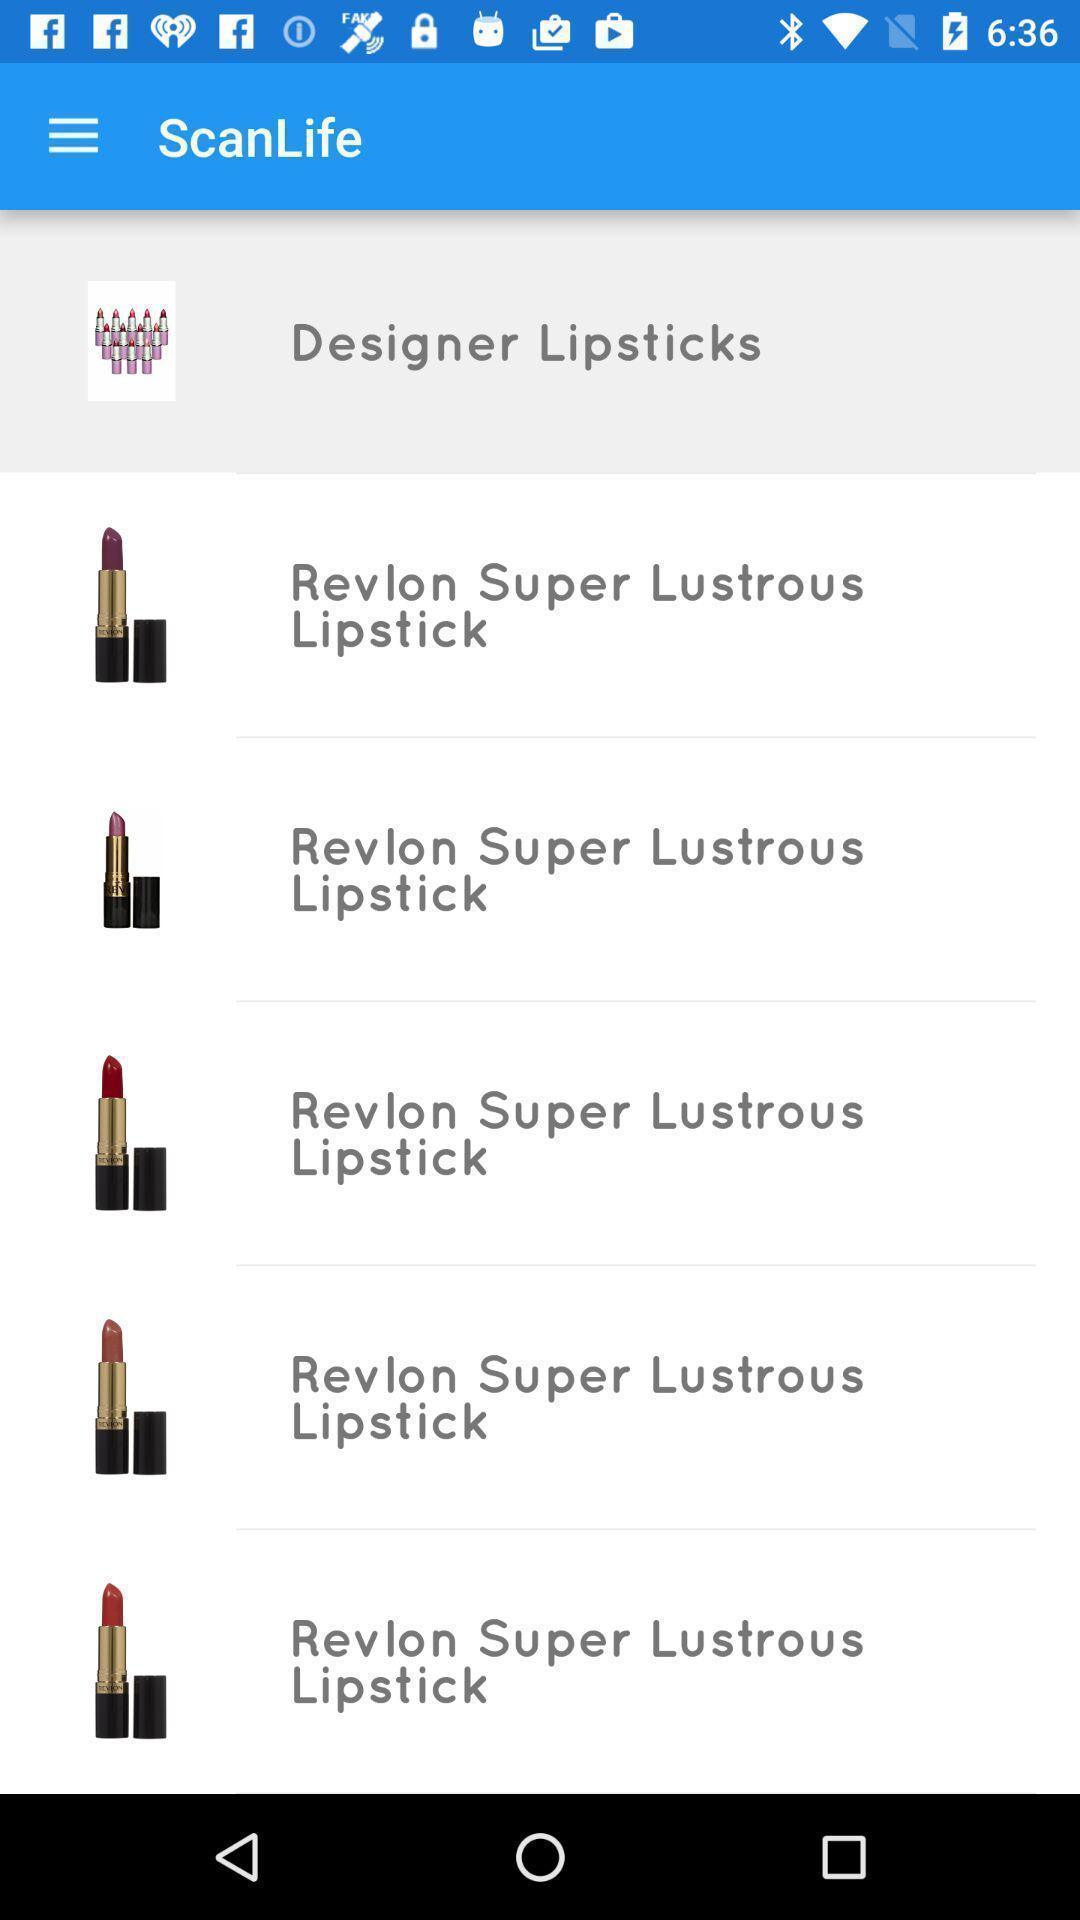What details can you identify in this image? Page with list of lipsticks in a shopping app. 